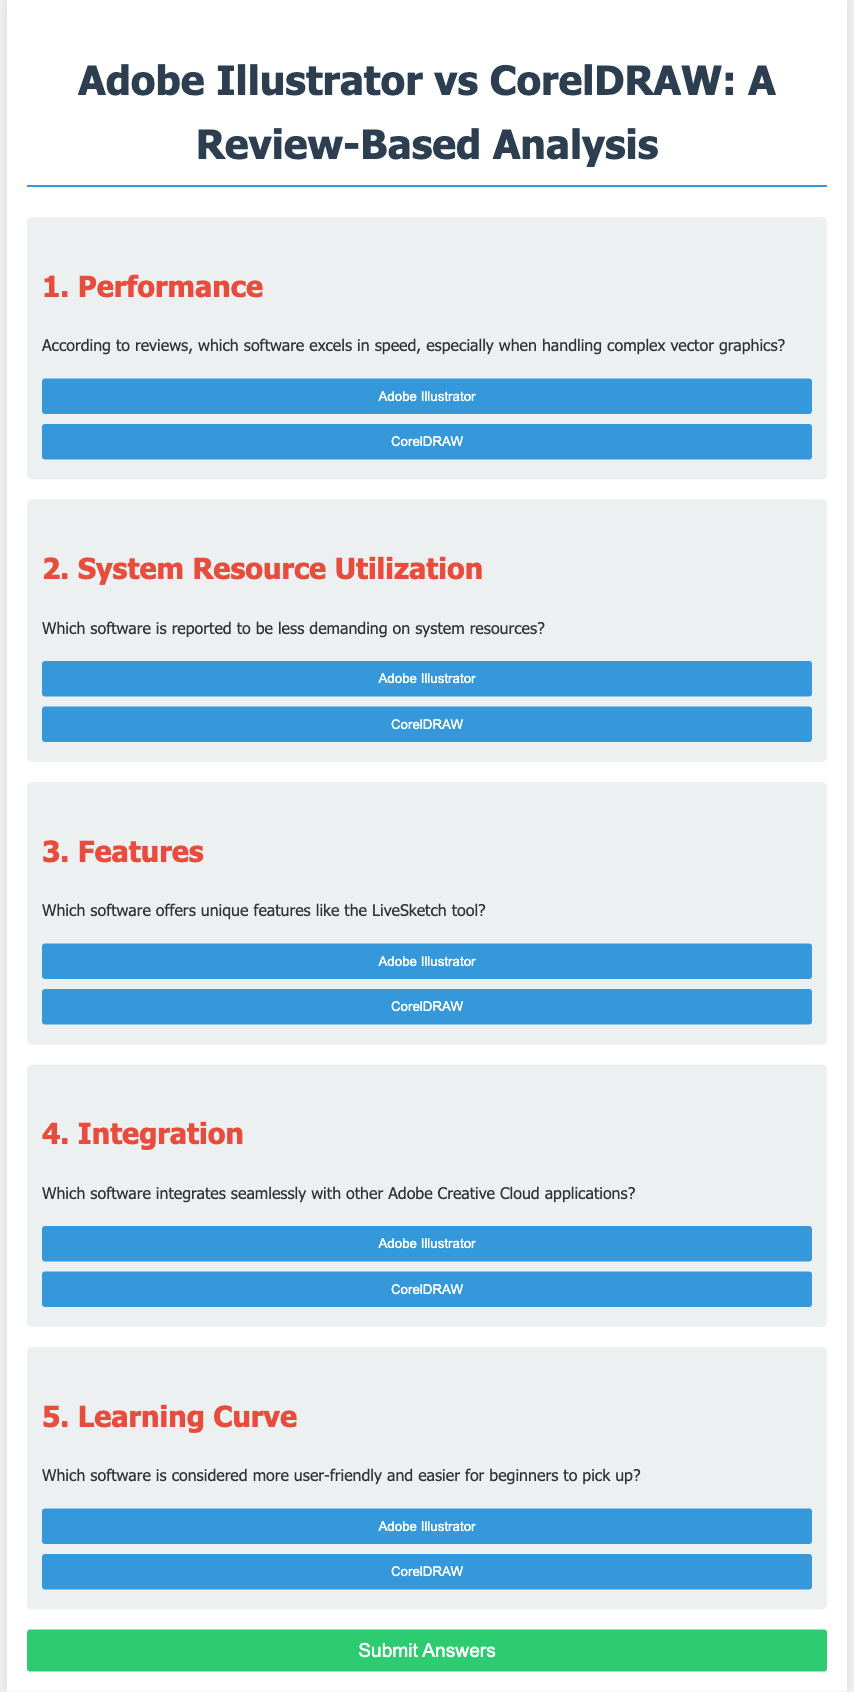What software excels in speed with complex vector graphics? The software that excels in speed, especially when handling complex vector graphics, is identified in the performance section of the document.
Answer: Adobe Illustrator Which software is less demanding on system resources? The document indicates which software is reported to be less demanding on system resources.
Answer: CorelDRAW What unique feature is mentioned in connection with CorelDRAW? The document specifies a unique feature offered by CorelDRAW.
Answer: LiveSketch tool Which software integrates seamlessly with Adobe Creative Cloud applications? The integration section of the document highlights which software integrates seamlessly with other Adobe applications.
Answer: Adobe Illustrator Which software is considered more user-friendly for beginners? The learning curve section discusses which software is easier for beginners to pick up.
Answer: CorelDRAW 